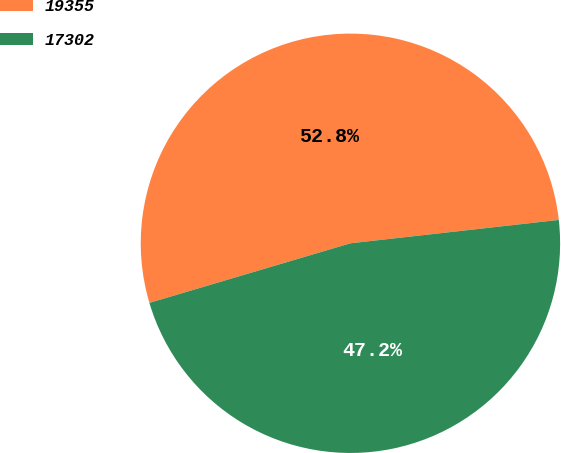<chart> <loc_0><loc_0><loc_500><loc_500><pie_chart><fcel>19355<fcel>17302<nl><fcel>52.81%<fcel>47.19%<nl></chart> 